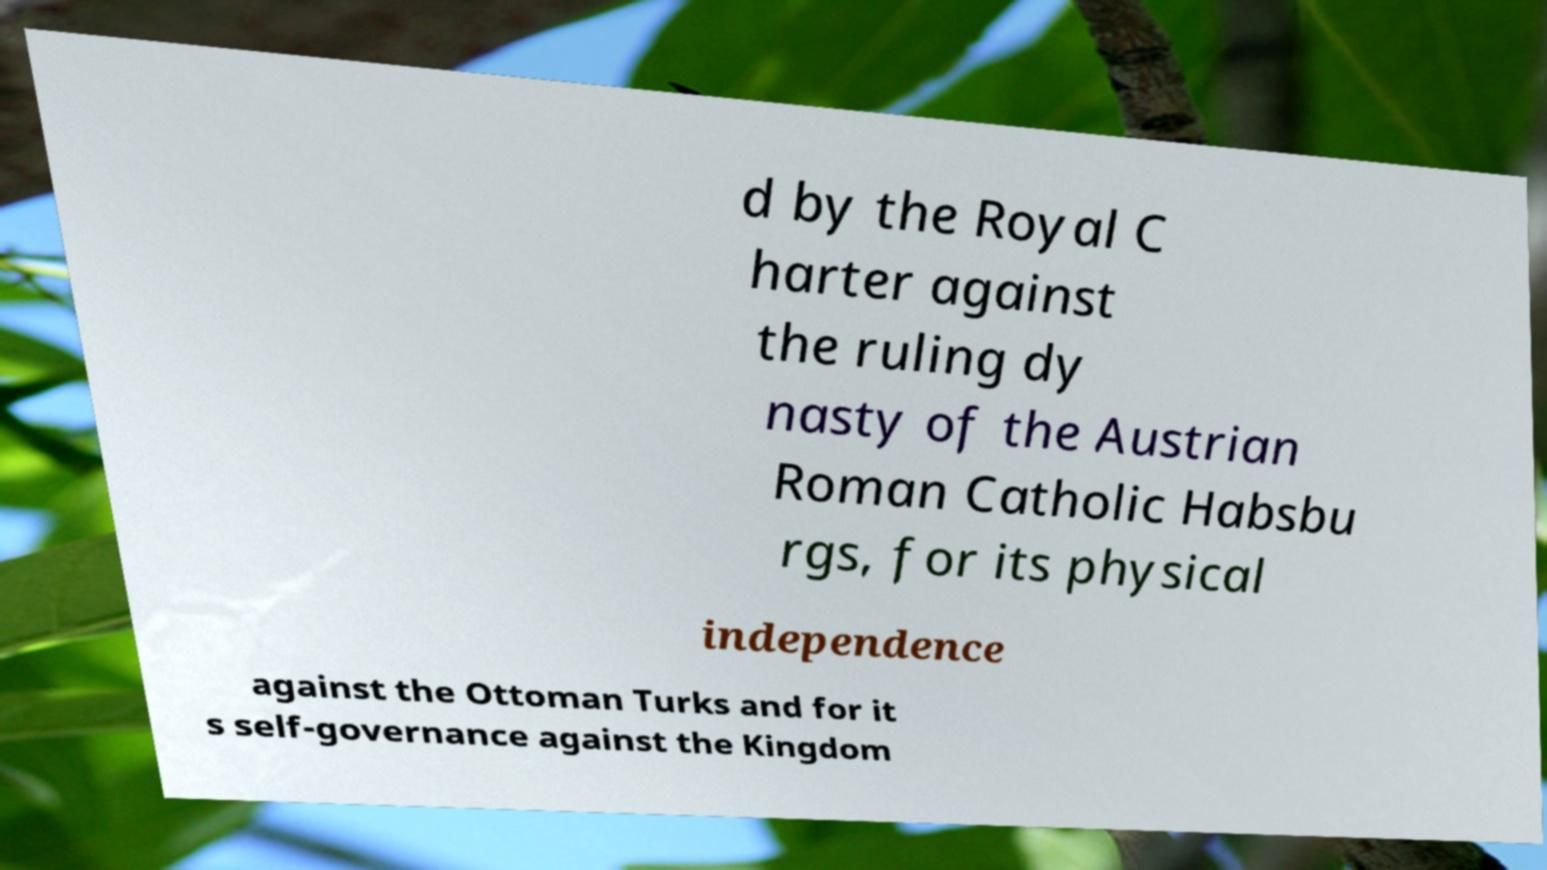Could you assist in decoding the text presented in this image and type it out clearly? d by the Royal C harter against the ruling dy nasty of the Austrian Roman Catholic Habsbu rgs, for its physical independence against the Ottoman Turks and for it s self-governance against the Kingdom 